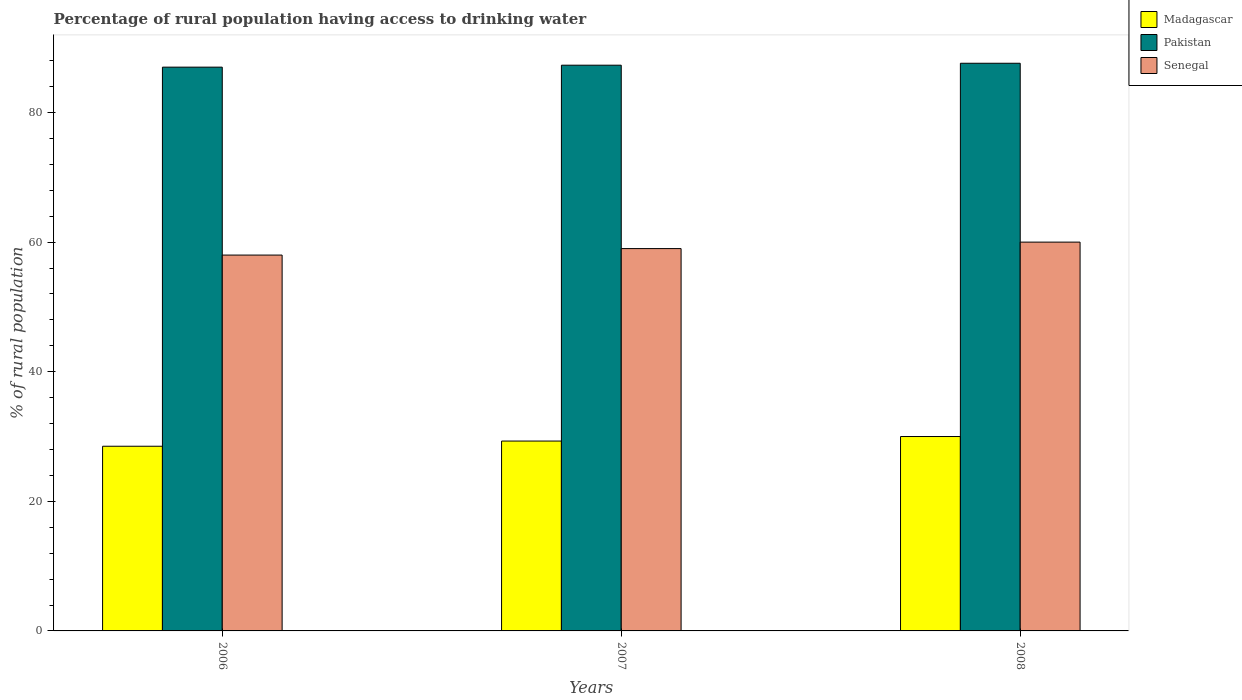Are the number of bars per tick equal to the number of legend labels?
Provide a short and direct response. Yes. Are the number of bars on each tick of the X-axis equal?
Give a very brief answer. Yes. In how many cases, is the number of bars for a given year not equal to the number of legend labels?
Give a very brief answer. 0. What is the percentage of rural population having access to drinking water in Pakistan in 2007?
Make the answer very short. 87.3. Across all years, what is the maximum percentage of rural population having access to drinking water in Senegal?
Offer a terse response. 60. In which year was the percentage of rural population having access to drinking water in Pakistan maximum?
Your answer should be compact. 2008. What is the total percentage of rural population having access to drinking water in Pakistan in the graph?
Keep it short and to the point. 261.9. What is the difference between the percentage of rural population having access to drinking water in Senegal in 2007 and that in 2008?
Give a very brief answer. -1. What is the difference between the percentage of rural population having access to drinking water in Senegal in 2008 and the percentage of rural population having access to drinking water in Madagascar in 2006?
Provide a short and direct response. 31.5. In the year 2008, what is the difference between the percentage of rural population having access to drinking water in Senegal and percentage of rural population having access to drinking water in Pakistan?
Give a very brief answer. -27.6. In how many years, is the percentage of rural population having access to drinking water in Madagascar greater than 56 %?
Your answer should be very brief. 0. What is the ratio of the percentage of rural population having access to drinking water in Senegal in 2006 to that in 2007?
Provide a short and direct response. 0.98. Is the percentage of rural population having access to drinking water in Madagascar in 2006 less than that in 2008?
Provide a succinct answer. Yes. What is the difference between the highest and the second highest percentage of rural population having access to drinking water in Pakistan?
Ensure brevity in your answer.  0.3. What does the 3rd bar from the left in 2008 represents?
Your response must be concise. Senegal. What does the 1st bar from the right in 2008 represents?
Provide a short and direct response. Senegal. How many bars are there?
Ensure brevity in your answer.  9. What is the difference between two consecutive major ticks on the Y-axis?
Give a very brief answer. 20. Are the values on the major ticks of Y-axis written in scientific E-notation?
Your response must be concise. No. Does the graph contain any zero values?
Provide a succinct answer. No. Does the graph contain grids?
Keep it short and to the point. No. Where does the legend appear in the graph?
Your answer should be very brief. Top right. What is the title of the graph?
Provide a succinct answer. Percentage of rural population having access to drinking water. Does "Least developed countries" appear as one of the legend labels in the graph?
Your answer should be very brief. No. What is the label or title of the Y-axis?
Keep it short and to the point. % of rural population. What is the % of rural population of Senegal in 2006?
Provide a succinct answer. 58. What is the % of rural population in Madagascar in 2007?
Ensure brevity in your answer.  29.3. What is the % of rural population in Pakistan in 2007?
Offer a very short reply. 87.3. What is the % of rural population in Senegal in 2007?
Provide a short and direct response. 59. What is the % of rural population of Pakistan in 2008?
Keep it short and to the point. 87.6. What is the % of rural population in Senegal in 2008?
Your answer should be very brief. 60. Across all years, what is the maximum % of rural population in Madagascar?
Make the answer very short. 30. Across all years, what is the maximum % of rural population in Pakistan?
Provide a succinct answer. 87.6. Across all years, what is the maximum % of rural population in Senegal?
Your answer should be compact. 60. Across all years, what is the minimum % of rural population in Pakistan?
Give a very brief answer. 87. Across all years, what is the minimum % of rural population in Senegal?
Your answer should be compact. 58. What is the total % of rural population of Madagascar in the graph?
Offer a very short reply. 87.8. What is the total % of rural population in Pakistan in the graph?
Offer a terse response. 261.9. What is the total % of rural population in Senegal in the graph?
Offer a very short reply. 177. What is the difference between the % of rural population of Madagascar in 2006 and that in 2007?
Keep it short and to the point. -0.8. What is the difference between the % of rural population in Pakistan in 2006 and that in 2007?
Your answer should be very brief. -0.3. What is the difference between the % of rural population of Senegal in 2006 and that in 2007?
Ensure brevity in your answer.  -1. What is the difference between the % of rural population in Madagascar in 2006 and that in 2008?
Your answer should be compact. -1.5. What is the difference between the % of rural population of Senegal in 2006 and that in 2008?
Provide a short and direct response. -2. What is the difference between the % of rural population in Madagascar in 2007 and that in 2008?
Your response must be concise. -0.7. What is the difference between the % of rural population of Madagascar in 2006 and the % of rural population of Pakistan in 2007?
Make the answer very short. -58.8. What is the difference between the % of rural population of Madagascar in 2006 and the % of rural population of Senegal in 2007?
Offer a very short reply. -30.5. What is the difference between the % of rural population of Madagascar in 2006 and the % of rural population of Pakistan in 2008?
Keep it short and to the point. -59.1. What is the difference between the % of rural population of Madagascar in 2006 and the % of rural population of Senegal in 2008?
Your response must be concise. -31.5. What is the difference between the % of rural population in Pakistan in 2006 and the % of rural population in Senegal in 2008?
Ensure brevity in your answer.  27. What is the difference between the % of rural population in Madagascar in 2007 and the % of rural population in Pakistan in 2008?
Provide a succinct answer. -58.3. What is the difference between the % of rural population in Madagascar in 2007 and the % of rural population in Senegal in 2008?
Your response must be concise. -30.7. What is the difference between the % of rural population in Pakistan in 2007 and the % of rural population in Senegal in 2008?
Your answer should be compact. 27.3. What is the average % of rural population in Madagascar per year?
Give a very brief answer. 29.27. What is the average % of rural population in Pakistan per year?
Provide a short and direct response. 87.3. In the year 2006, what is the difference between the % of rural population of Madagascar and % of rural population of Pakistan?
Make the answer very short. -58.5. In the year 2006, what is the difference between the % of rural population in Madagascar and % of rural population in Senegal?
Keep it short and to the point. -29.5. In the year 2006, what is the difference between the % of rural population of Pakistan and % of rural population of Senegal?
Your answer should be compact. 29. In the year 2007, what is the difference between the % of rural population of Madagascar and % of rural population of Pakistan?
Provide a succinct answer. -58. In the year 2007, what is the difference between the % of rural population in Madagascar and % of rural population in Senegal?
Offer a very short reply. -29.7. In the year 2007, what is the difference between the % of rural population of Pakistan and % of rural population of Senegal?
Provide a succinct answer. 28.3. In the year 2008, what is the difference between the % of rural population in Madagascar and % of rural population in Pakistan?
Offer a very short reply. -57.6. In the year 2008, what is the difference between the % of rural population in Pakistan and % of rural population in Senegal?
Make the answer very short. 27.6. What is the ratio of the % of rural population of Madagascar in 2006 to that in 2007?
Offer a very short reply. 0.97. What is the ratio of the % of rural population in Pakistan in 2006 to that in 2007?
Keep it short and to the point. 1. What is the ratio of the % of rural population in Senegal in 2006 to that in 2007?
Make the answer very short. 0.98. What is the ratio of the % of rural population of Madagascar in 2006 to that in 2008?
Your response must be concise. 0.95. What is the ratio of the % of rural population of Senegal in 2006 to that in 2008?
Your answer should be compact. 0.97. What is the ratio of the % of rural population in Madagascar in 2007 to that in 2008?
Offer a terse response. 0.98. What is the ratio of the % of rural population in Senegal in 2007 to that in 2008?
Offer a terse response. 0.98. What is the difference between the highest and the second highest % of rural population in Madagascar?
Ensure brevity in your answer.  0.7. What is the difference between the highest and the second highest % of rural population in Pakistan?
Your answer should be compact. 0.3. What is the difference between the highest and the second highest % of rural population of Senegal?
Your answer should be very brief. 1. What is the difference between the highest and the lowest % of rural population in Senegal?
Offer a terse response. 2. 